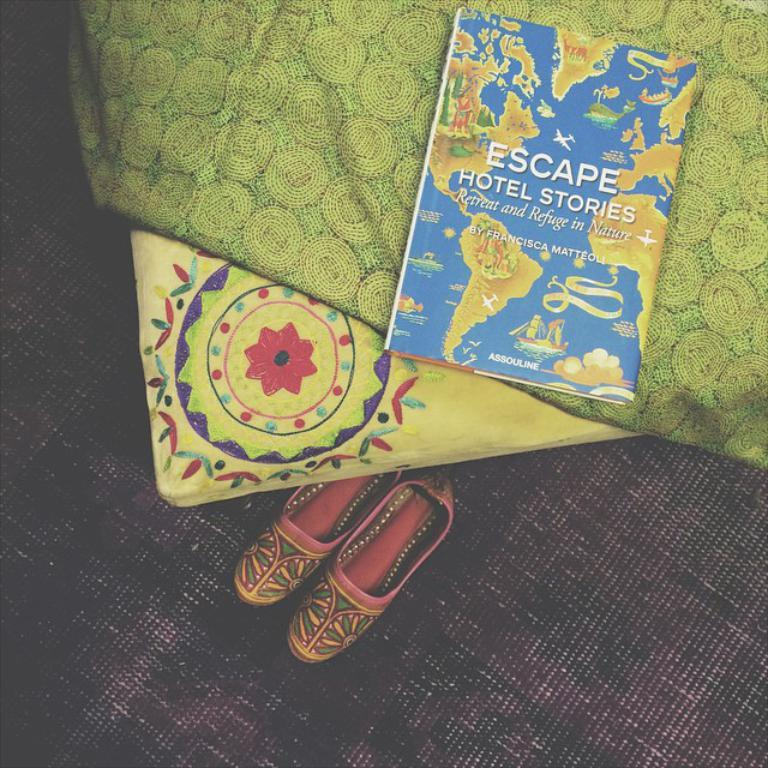<image>
Render a clear and concise summary of the photo. a book titled "Escape Hotel Stories" sits on a bed 